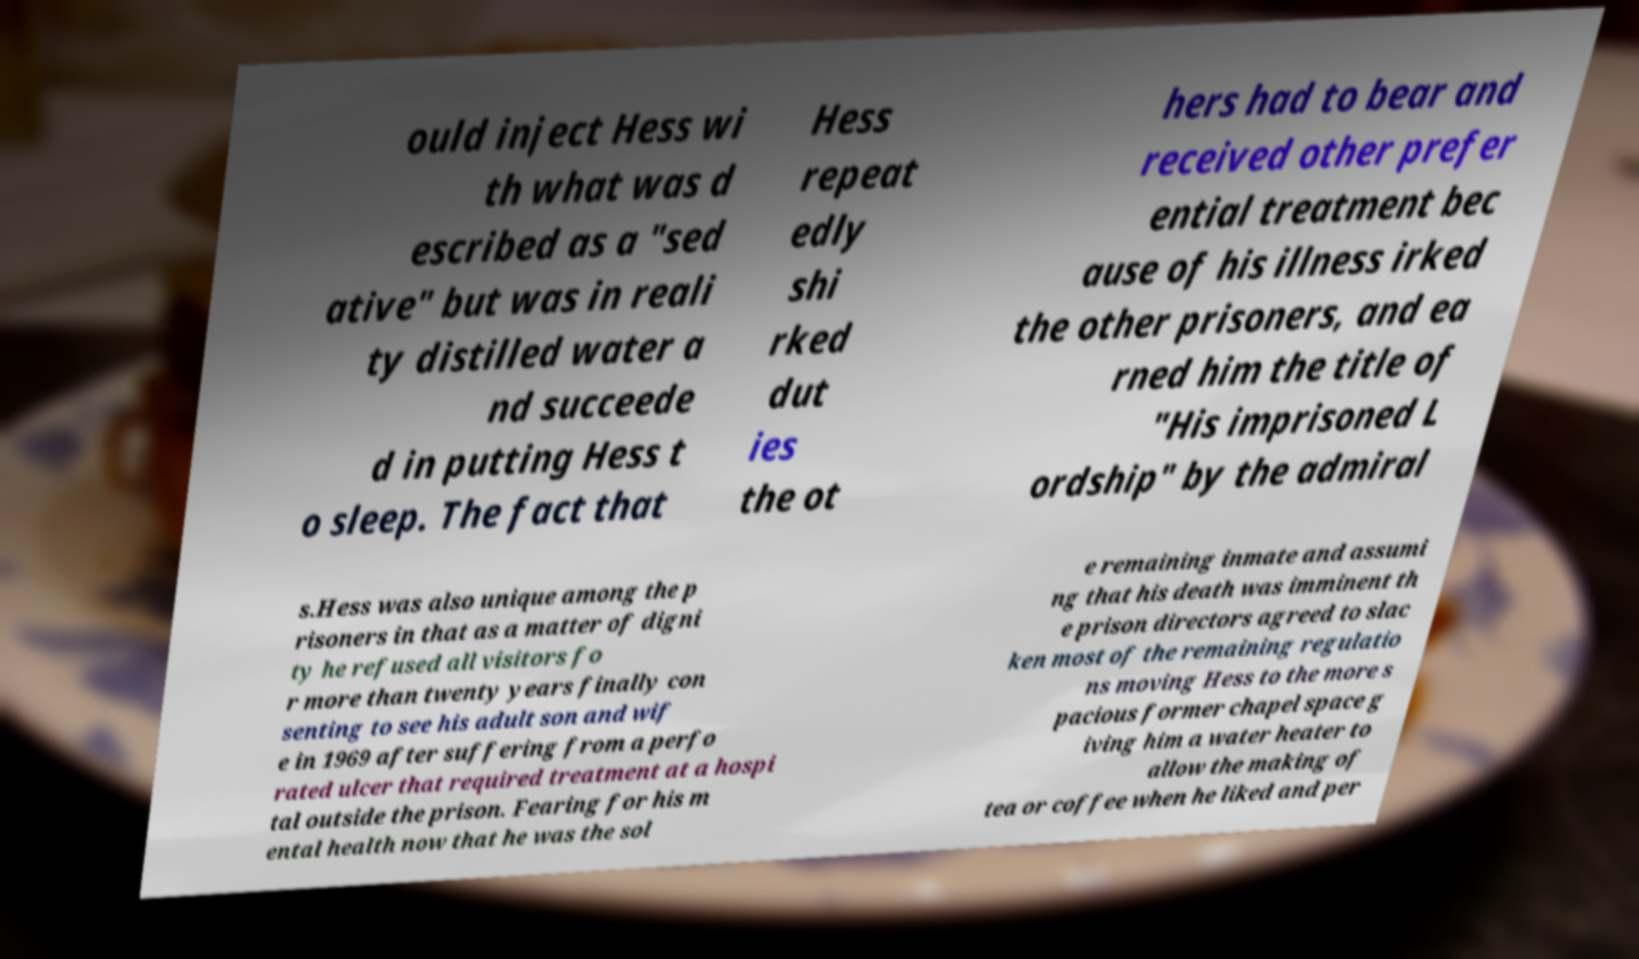For documentation purposes, I need the text within this image transcribed. Could you provide that? ould inject Hess wi th what was d escribed as a "sed ative" but was in reali ty distilled water a nd succeede d in putting Hess t o sleep. The fact that Hess repeat edly shi rked dut ies the ot hers had to bear and received other prefer ential treatment bec ause of his illness irked the other prisoners, and ea rned him the title of "His imprisoned L ordship" by the admiral s.Hess was also unique among the p risoners in that as a matter of digni ty he refused all visitors fo r more than twenty years finally con senting to see his adult son and wif e in 1969 after suffering from a perfo rated ulcer that required treatment at a hospi tal outside the prison. Fearing for his m ental health now that he was the sol e remaining inmate and assumi ng that his death was imminent th e prison directors agreed to slac ken most of the remaining regulatio ns moving Hess to the more s pacious former chapel space g iving him a water heater to allow the making of tea or coffee when he liked and per 